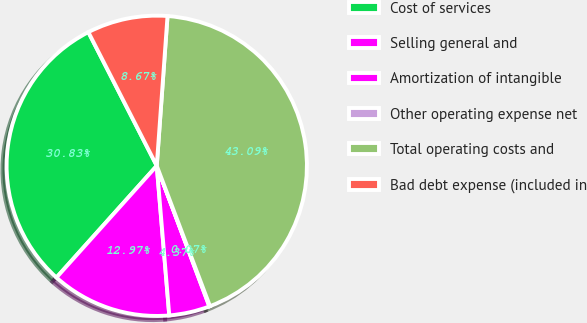Convert chart to OTSL. <chart><loc_0><loc_0><loc_500><loc_500><pie_chart><fcel>Cost of services<fcel>Selling general and<fcel>Amortization of intangible<fcel>Other operating expense net<fcel>Total operating costs and<fcel>Bad debt expense (included in<nl><fcel>30.83%<fcel>12.97%<fcel>4.37%<fcel>0.07%<fcel>43.09%<fcel>8.67%<nl></chart> 